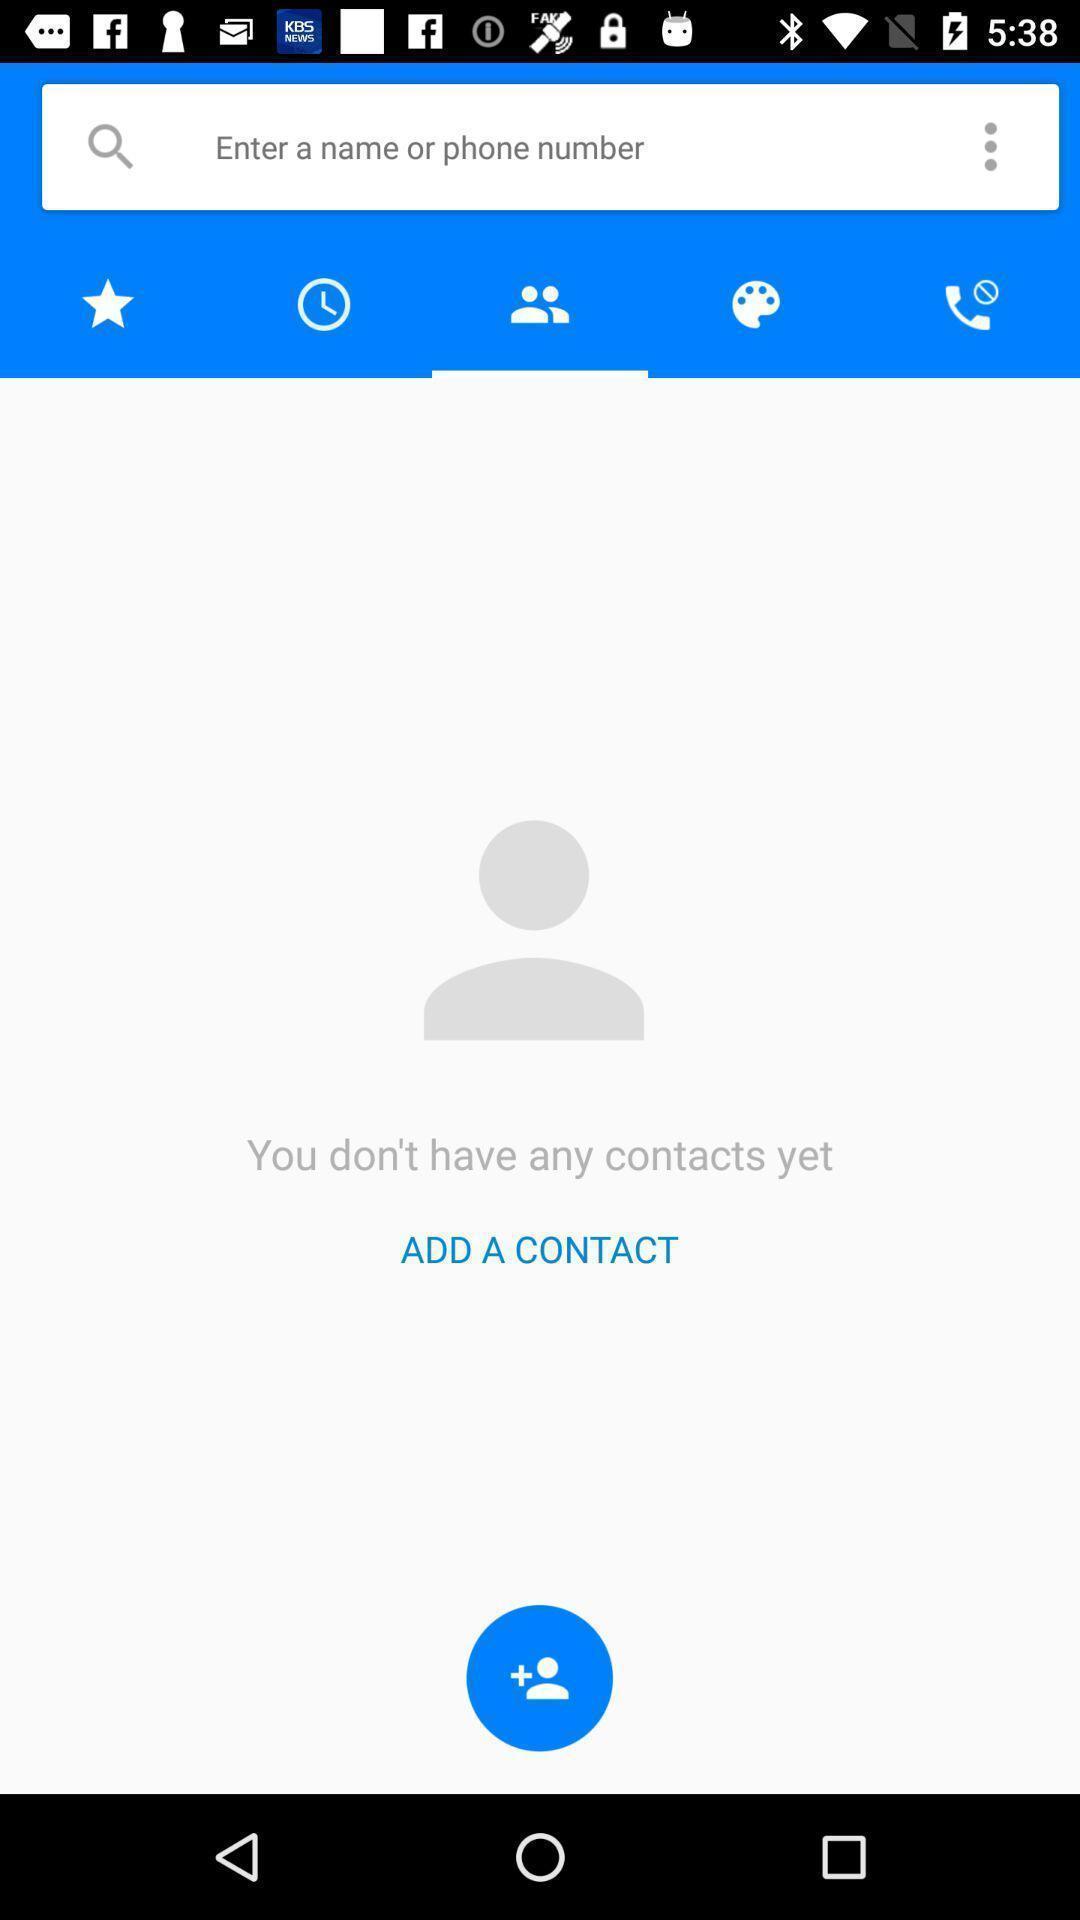What is the overall content of this screenshot? Search page for the contact app. 